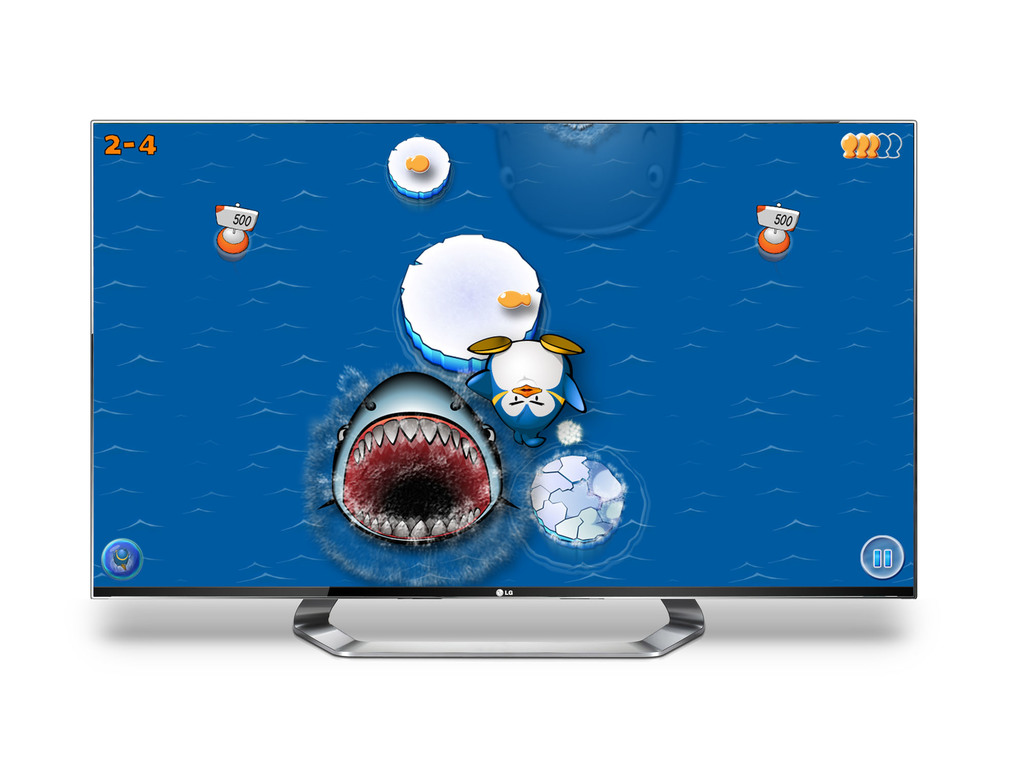What is the theme of the game shown in the image? The game's theme centers around a whimsical underwater adventure, featuring cartoon-style marine creatures and perilous obstacles. 